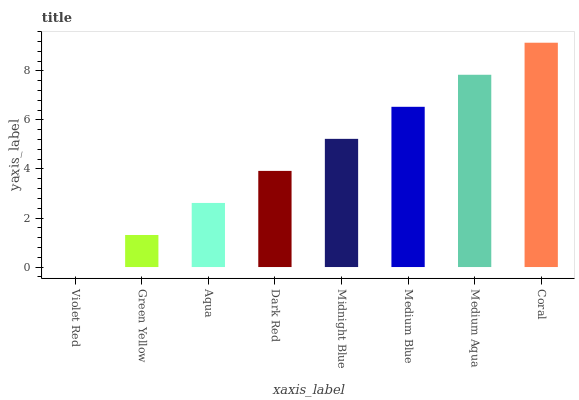Is Violet Red the minimum?
Answer yes or no. Yes. Is Coral the maximum?
Answer yes or no. Yes. Is Green Yellow the minimum?
Answer yes or no. No. Is Green Yellow the maximum?
Answer yes or no. No. Is Green Yellow greater than Violet Red?
Answer yes or no. Yes. Is Violet Red less than Green Yellow?
Answer yes or no. Yes. Is Violet Red greater than Green Yellow?
Answer yes or no. No. Is Green Yellow less than Violet Red?
Answer yes or no. No. Is Midnight Blue the high median?
Answer yes or no. Yes. Is Dark Red the low median?
Answer yes or no. Yes. Is Medium Blue the high median?
Answer yes or no. No. Is Aqua the low median?
Answer yes or no. No. 